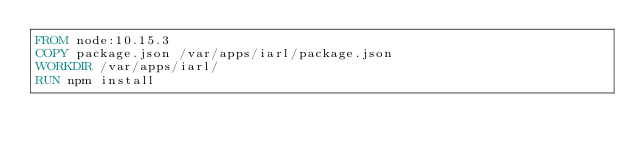<code> <loc_0><loc_0><loc_500><loc_500><_Dockerfile_>FROM node:10.15.3
COPY package.json /var/apps/iarl/package.json
WORKDIR /var/apps/iarl/
RUN npm install</code> 